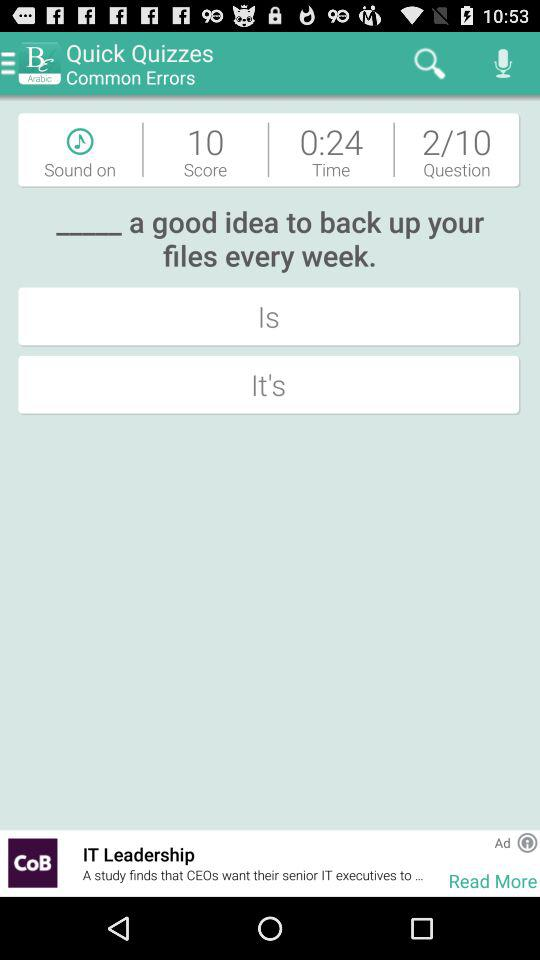How much time is left? The time left is 24 seconds. 